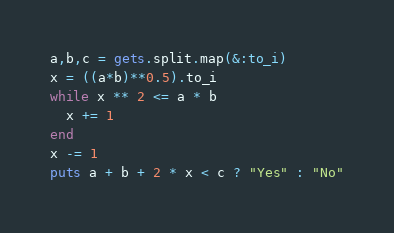<code> <loc_0><loc_0><loc_500><loc_500><_Ruby_>a,b,c = gets.split.map(&:to_i)
x = ((a*b)**0.5).to_i
while x ** 2 <= a * b
  x += 1
end
x -= 1
puts a + b + 2 * x < c ? "Yes" : "No"</code> 